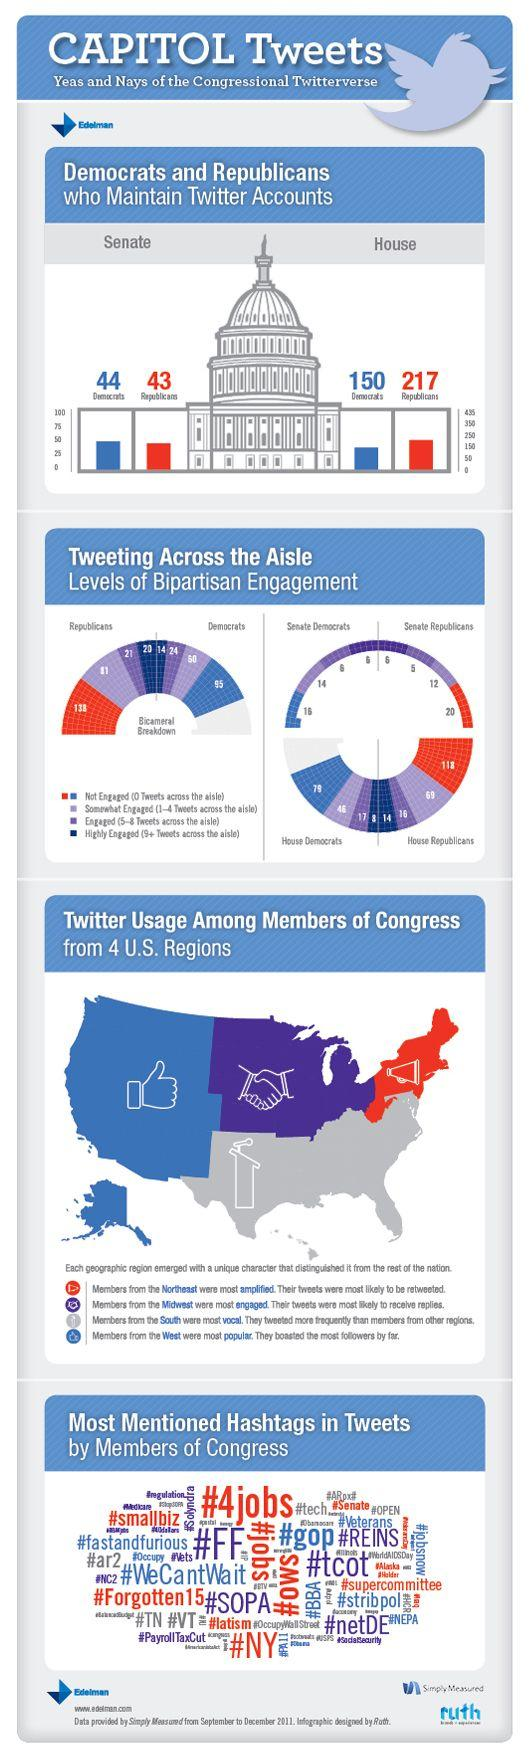Outline some significant characteristics in this image. The Democratic Party has more members of the Senate with multiple Twitter accounts than the Republican Party. The study found that the South region tweeted more frequently than the other places. There are currently 20 Republican Senators who are not using Twitter. There are 99 Republican representatives in the House who use Twitter. The hashtag "#4jobs" was the most frequently mentioned hashtag in tweets by Congressmen. 